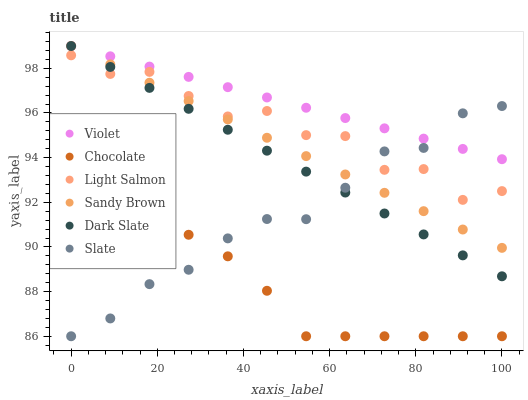Does Chocolate have the minimum area under the curve?
Answer yes or no. Yes. Does Violet have the maximum area under the curve?
Answer yes or no. Yes. Does Slate have the minimum area under the curve?
Answer yes or no. No. Does Slate have the maximum area under the curve?
Answer yes or no. No. Is Dark Slate the smoothest?
Answer yes or no. Yes. Is Light Salmon the roughest?
Answer yes or no. Yes. Is Slate the smoothest?
Answer yes or no. No. Is Slate the roughest?
Answer yes or no. No. Does Slate have the lowest value?
Answer yes or no. Yes. Does Dark Slate have the lowest value?
Answer yes or no. No. Does Sandy Brown have the highest value?
Answer yes or no. Yes. Does Slate have the highest value?
Answer yes or no. No. Is Chocolate less than Dark Slate?
Answer yes or no. Yes. Is Light Salmon greater than Chocolate?
Answer yes or no. Yes. Does Violet intersect Sandy Brown?
Answer yes or no. Yes. Is Violet less than Sandy Brown?
Answer yes or no. No. Is Violet greater than Sandy Brown?
Answer yes or no. No. Does Chocolate intersect Dark Slate?
Answer yes or no. No. 